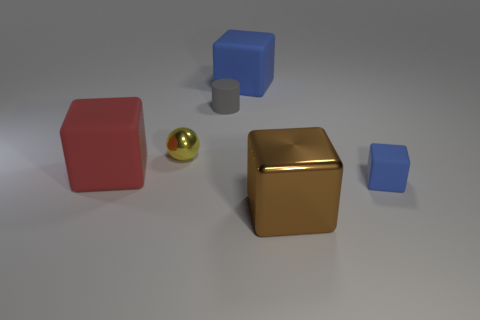There is a large object left of the gray rubber cylinder; is it the same shape as the blue rubber object behind the small blue rubber thing?
Your answer should be compact. Yes. Is there a yellow ball that has the same material as the brown object?
Offer a terse response. Yes. The tiny rubber thing that is on the left side of the large thing that is in front of the blue object that is in front of the sphere is what color?
Provide a short and direct response. Gray. Are the blue cube that is in front of the matte cylinder and the blue cube that is behind the tiny blue cube made of the same material?
Keep it short and to the point. Yes. There is a small rubber thing that is on the left side of the brown block; what is its shape?
Make the answer very short. Cylinder. What number of things are either tiny cyan metal cylinders or objects left of the small gray thing?
Give a very brief answer. 2. Do the gray object and the yellow thing have the same material?
Give a very brief answer. No. Are there an equal number of gray matte things that are to the right of the small gray thing and tiny matte cubes that are on the right side of the brown metallic thing?
Your response must be concise. No. There is a shiny ball; what number of big red rubber blocks are behind it?
Provide a succinct answer. 0. How many objects are either small cylinders or blue matte blocks?
Offer a very short reply. 3. 